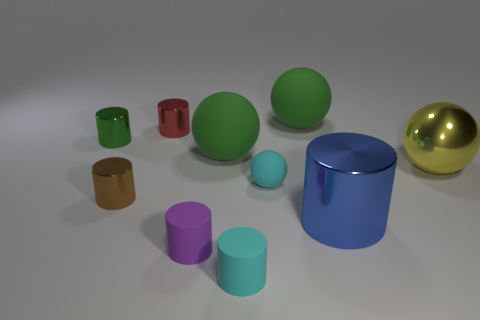How does the lighting in the image affect the appearance of the objects? The lighting in the image appears to be soft and diffused, casting gentle shadows and contributing to the objects' three-dimensionality. It enhances the viewer's ability to perceive the shapes and colors accurately, although the lack of stronger light and shadow contrast might make it difficult to analyze the textures and materials in depth. 